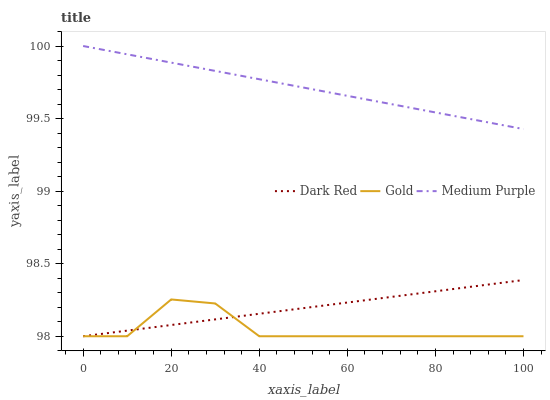Does Gold have the minimum area under the curve?
Answer yes or no. Yes. Does Medium Purple have the maximum area under the curve?
Answer yes or no. Yes. Does Dark Red have the minimum area under the curve?
Answer yes or no. No. Does Dark Red have the maximum area under the curve?
Answer yes or no. No. Is Dark Red the smoothest?
Answer yes or no. Yes. Is Gold the roughest?
Answer yes or no. Yes. Is Gold the smoothest?
Answer yes or no. No. Is Dark Red the roughest?
Answer yes or no. No. Does Dark Red have the lowest value?
Answer yes or no. Yes. Does Medium Purple have the highest value?
Answer yes or no. Yes. Does Dark Red have the highest value?
Answer yes or no. No. Is Gold less than Medium Purple?
Answer yes or no. Yes. Is Medium Purple greater than Dark Red?
Answer yes or no. Yes. Does Gold intersect Dark Red?
Answer yes or no. Yes. Is Gold less than Dark Red?
Answer yes or no. No. Is Gold greater than Dark Red?
Answer yes or no. No. Does Gold intersect Medium Purple?
Answer yes or no. No. 